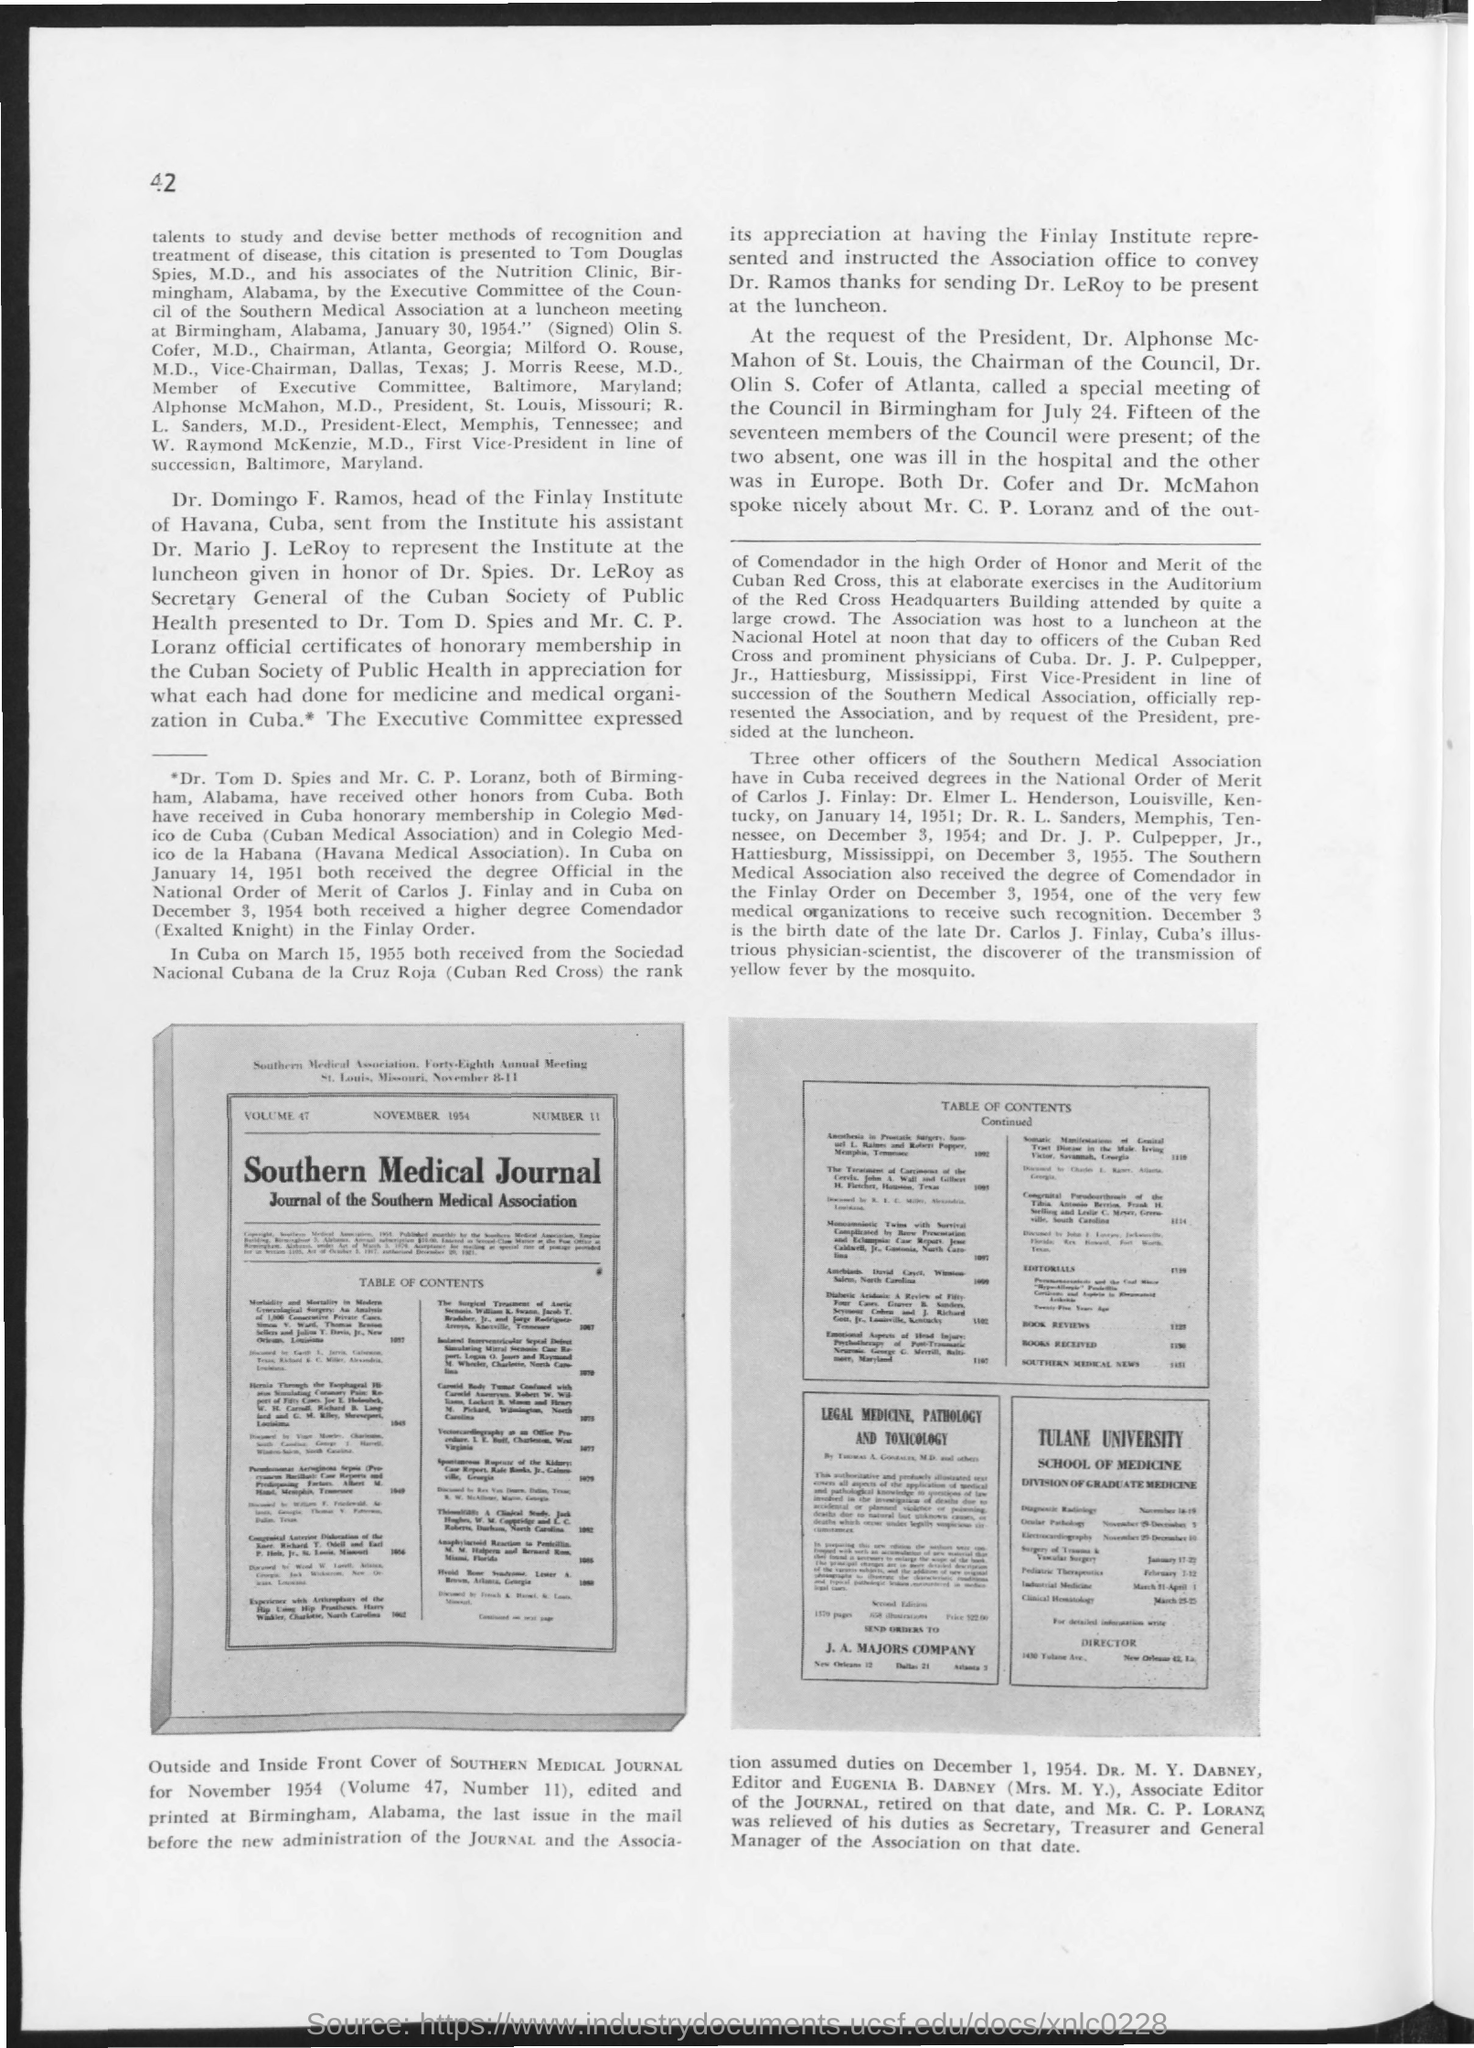List a handful of essential elements in this visual. I hereby declare that the late Dr. Carlos J. Finlay was born on December 3. The page number at the left top corner of the page is 42. Provide the "volume" number mentioned in the journal, which is 47. The Southern Medical Journal was edited by Dr. M.Y. Dabney. The image represents the cover of the November 1954 issue of the Southern Medical Journal. 